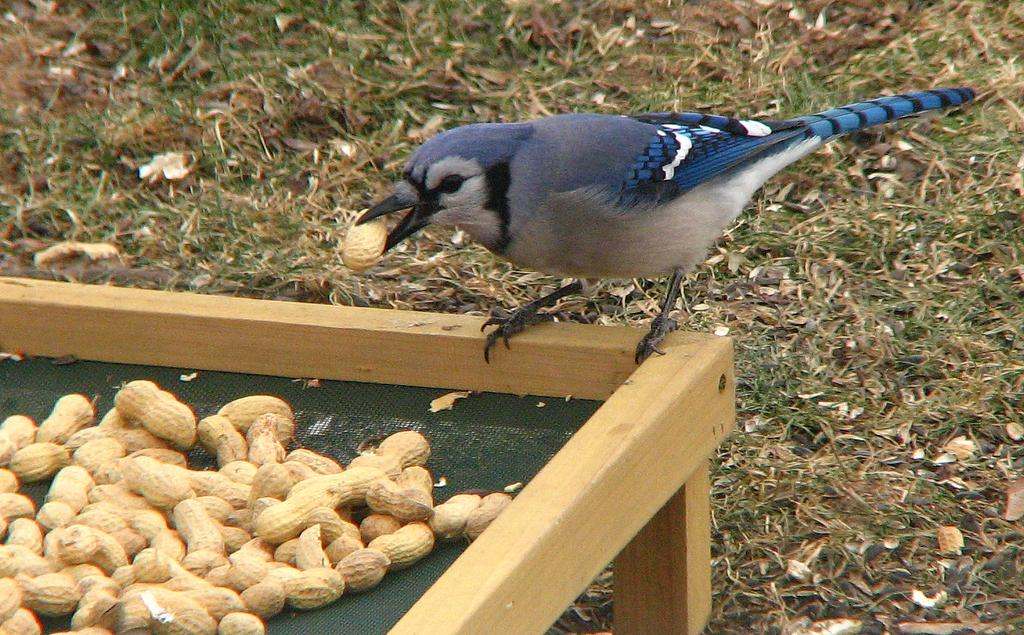What type of animal can be seen in the image? There is a bird in the image. Where is the bird located? The bird is standing on a wooden table. What is on the wooden table besides the bird? There are peanuts on the wooden table. What type of surface is visible at the bottom of the image? There is grass visible at the bottom of the image. What type of territory does the bird suggest in the image? The image does not depict a territory, nor does the bird suggest one. 